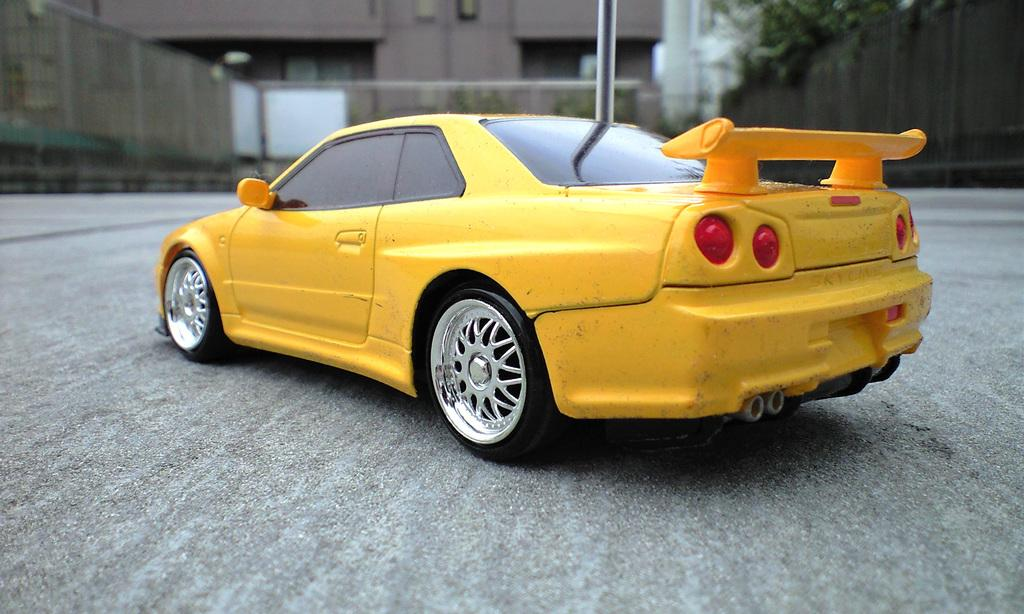What is the main subject of the image? There is a car in the center of the image. What color is the car? The car is yellow in color. What can be seen in the background of the image? There are trees and a building in the background of the image. What type of fear can be seen on the faces of the trees in the image? There is no indication of fear on the faces of the trees, as trees do not have faces. 